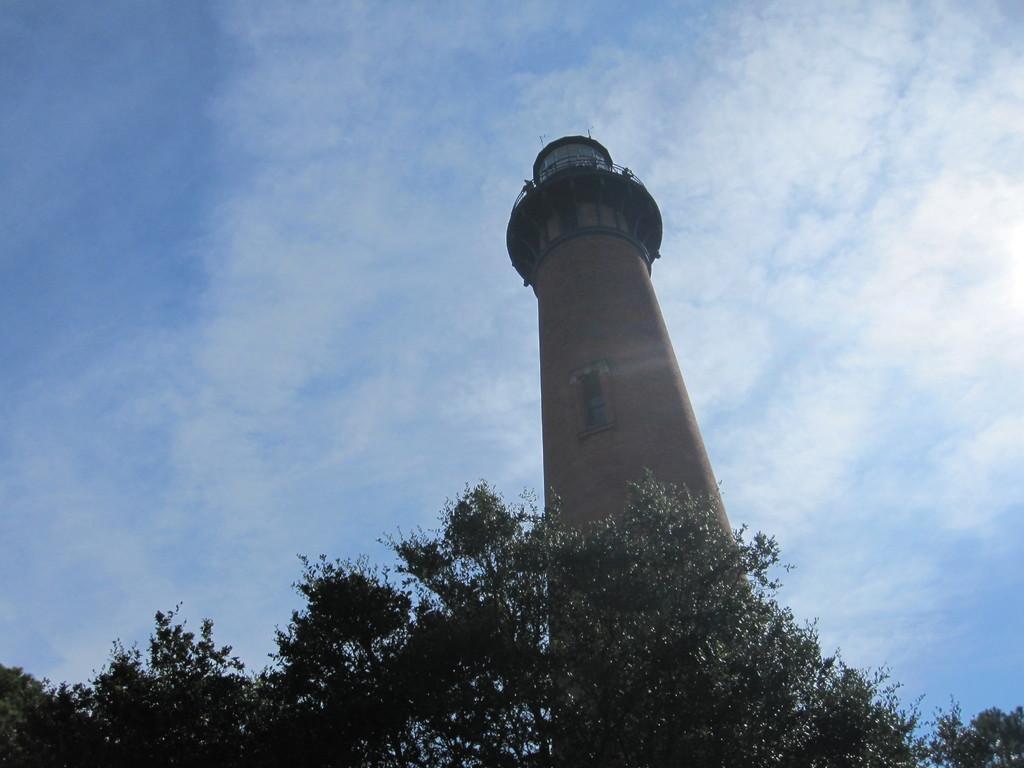Please provide a concise description of this image. In this picture there is a huge lighthouse tower in the middle of the image. In the front there are some trees. 